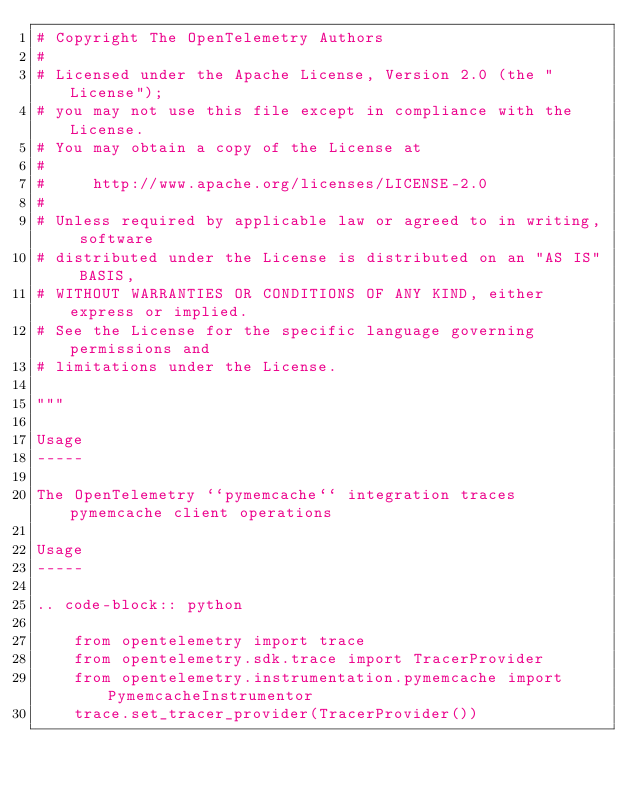<code> <loc_0><loc_0><loc_500><loc_500><_Python_># Copyright The OpenTelemetry Authors
#
# Licensed under the Apache License, Version 2.0 (the "License");
# you may not use this file except in compliance with the License.
# You may obtain a copy of the License at
#
#     http://www.apache.org/licenses/LICENSE-2.0
#
# Unless required by applicable law or agreed to in writing, software
# distributed under the License is distributed on an "AS IS" BASIS,
# WITHOUT WARRANTIES OR CONDITIONS OF ANY KIND, either express or implied.
# See the License for the specific language governing permissions and
# limitations under the License.

"""

Usage
-----

The OpenTelemetry ``pymemcache`` integration traces pymemcache client operations

Usage
-----

.. code-block:: python

    from opentelemetry import trace
    from opentelemetry.sdk.trace import TracerProvider
    from opentelemetry.instrumentation.pymemcache import PymemcacheInstrumentor
    trace.set_tracer_provider(TracerProvider())</code> 